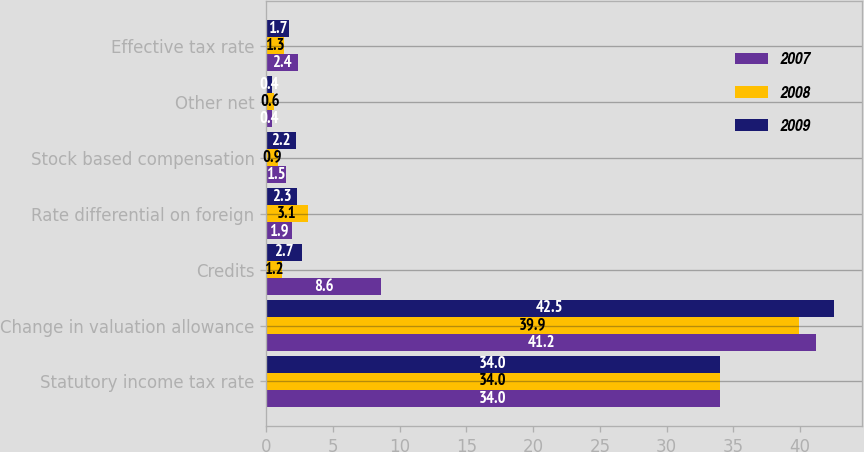<chart> <loc_0><loc_0><loc_500><loc_500><stacked_bar_chart><ecel><fcel>Statutory income tax rate<fcel>Change in valuation allowance<fcel>Credits<fcel>Rate differential on foreign<fcel>Stock based compensation<fcel>Other net<fcel>Effective tax rate<nl><fcel>2007<fcel>34<fcel>41.2<fcel>8.6<fcel>1.9<fcel>1.5<fcel>0.4<fcel>2.4<nl><fcel>2008<fcel>34<fcel>39.9<fcel>1.2<fcel>3.1<fcel>0.9<fcel>0.6<fcel>1.3<nl><fcel>2009<fcel>34<fcel>42.5<fcel>2.7<fcel>2.3<fcel>2.2<fcel>0.4<fcel>1.7<nl></chart> 